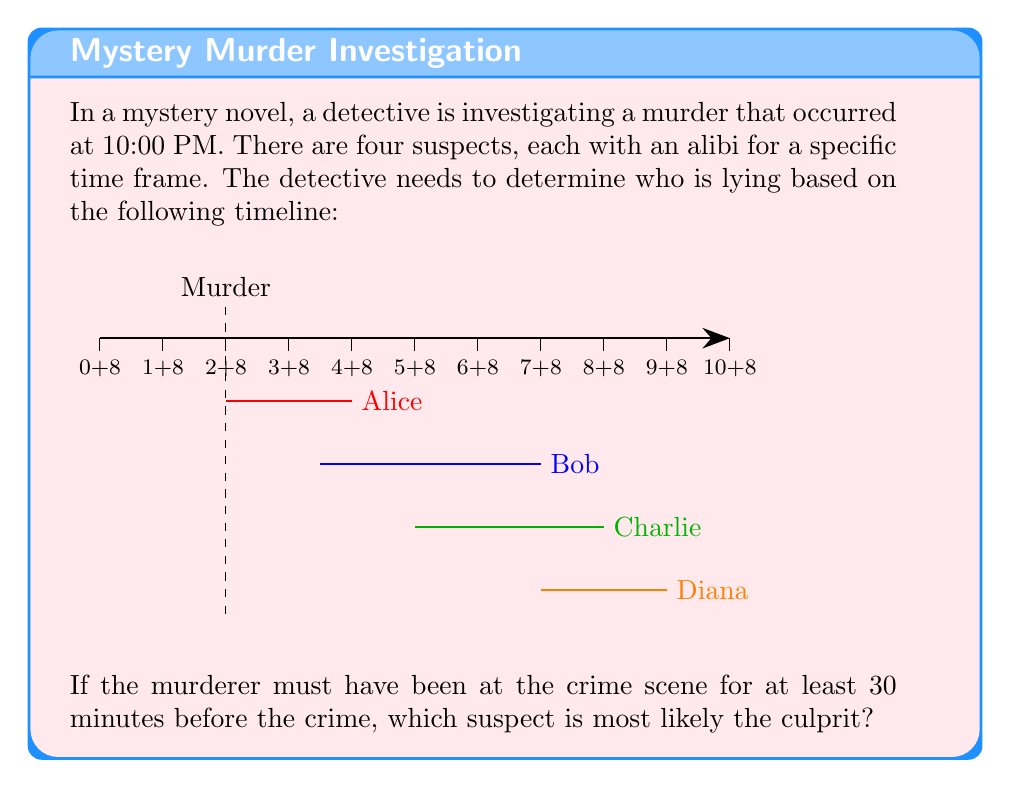Show me your answer to this math problem. To solve this logic puzzle, we need to analyze each suspect's alibi in relation to the murder time:

1. The murder occurred at 10:00 PM (2 on the timeline).
2. The murderer needed to be at the scene 30 minutes before, so from 9:30 PM (1.5 on the timeline).

Let's examine each suspect's alibi:

1. Alice: Alibi from 10:00 PM to 12:00 AM (2 to 4 on the timeline)
   - Alice's alibi starts exactly at the murder time, so she could have been at the scene 30 minutes prior.

2. Bob: Alibi from 11:30 PM to 3:00 AM (3.5 to 7 on the timeline)
   - Bob's alibi starts after the murder, so he's a possible suspect.

3. Charlie: Alibi from 1:00 AM to 4:00 AM (5 to 8 on the timeline)
   - Charlie's alibi also starts after the murder, making him a possible suspect.

4. Diana: Alibi from 3:00 AM to 5:00 AM (7 to 9 on the timeline)
   - Diana's alibi is the latest, also starting after the murder.

Among these suspects, Alice is the only one whose alibi overlaps with the murder time. However, her alibi starts exactly at 10:00 PM, which means she could have been at the crime scene for the required 30 minutes before the murder.

The other suspects (Bob, Charlie, and Diana) all have alibis that start after the murder, so they remain potential culprits. However, Alice's alibi makes her the most suspicious, as it seems tailored to provide coverage immediately after the crime.
Answer: Alice 